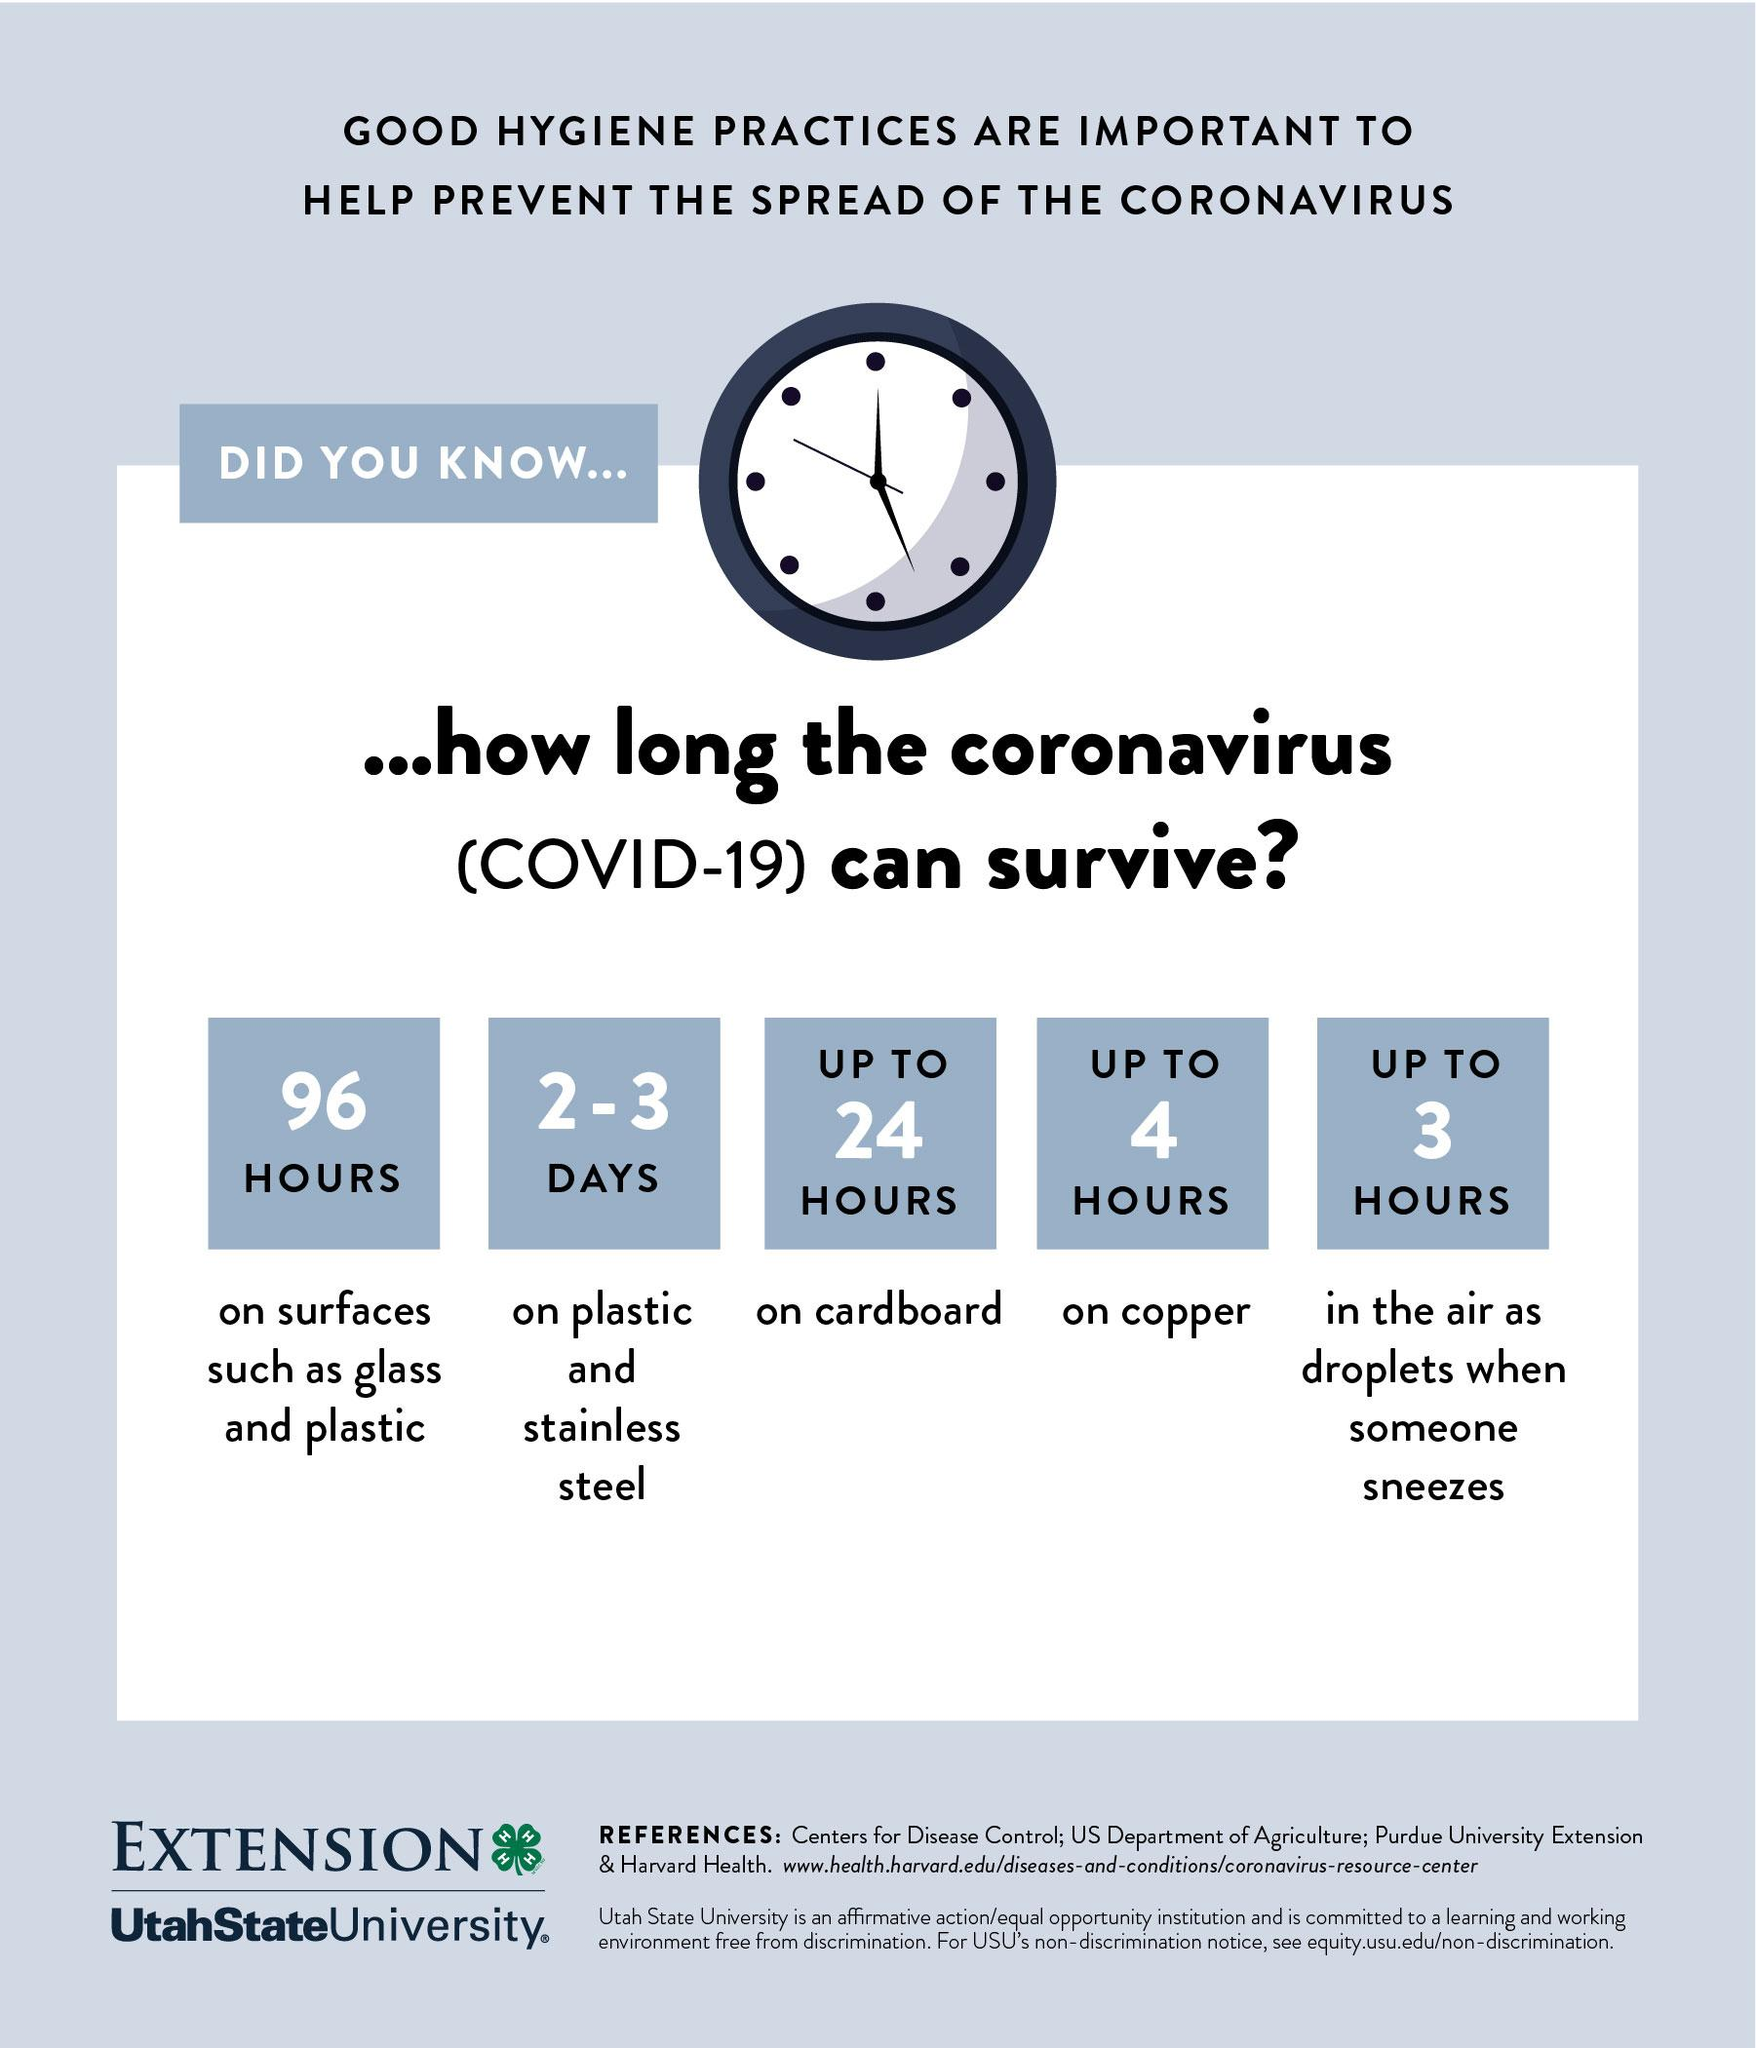Outline some significant characteristics in this image. The virus can survive for a period of 96 hours on glass surfaces, The virus can survive for up to 3 hours in air as droplets, providing a prolonged potential for transmission. The virus can survive for up to 4 hours on copper, according to research. The virus can survive for 2-3 days on stainless steel. The viral contamination can persist on cardboard for up to 24 hours. 